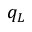<formula> <loc_0><loc_0><loc_500><loc_500>q _ { L }</formula> 